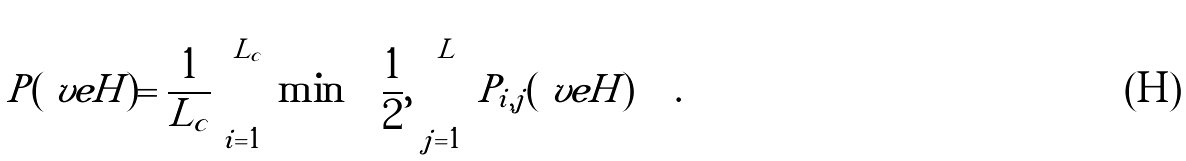Convert formula to latex. <formula><loc_0><loc_0><loc_500><loc_500>P ( \ v e { H } ) = \frac { 1 } { L _ { c } } \sum _ { i = 1 } ^ { L _ { c } } \min \left [ \frac { 1 } { 2 } , \sum _ { j = 1 } ^ { L } P _ { i , j } ( \ v e { H } ) \right ] \, .</formula> 